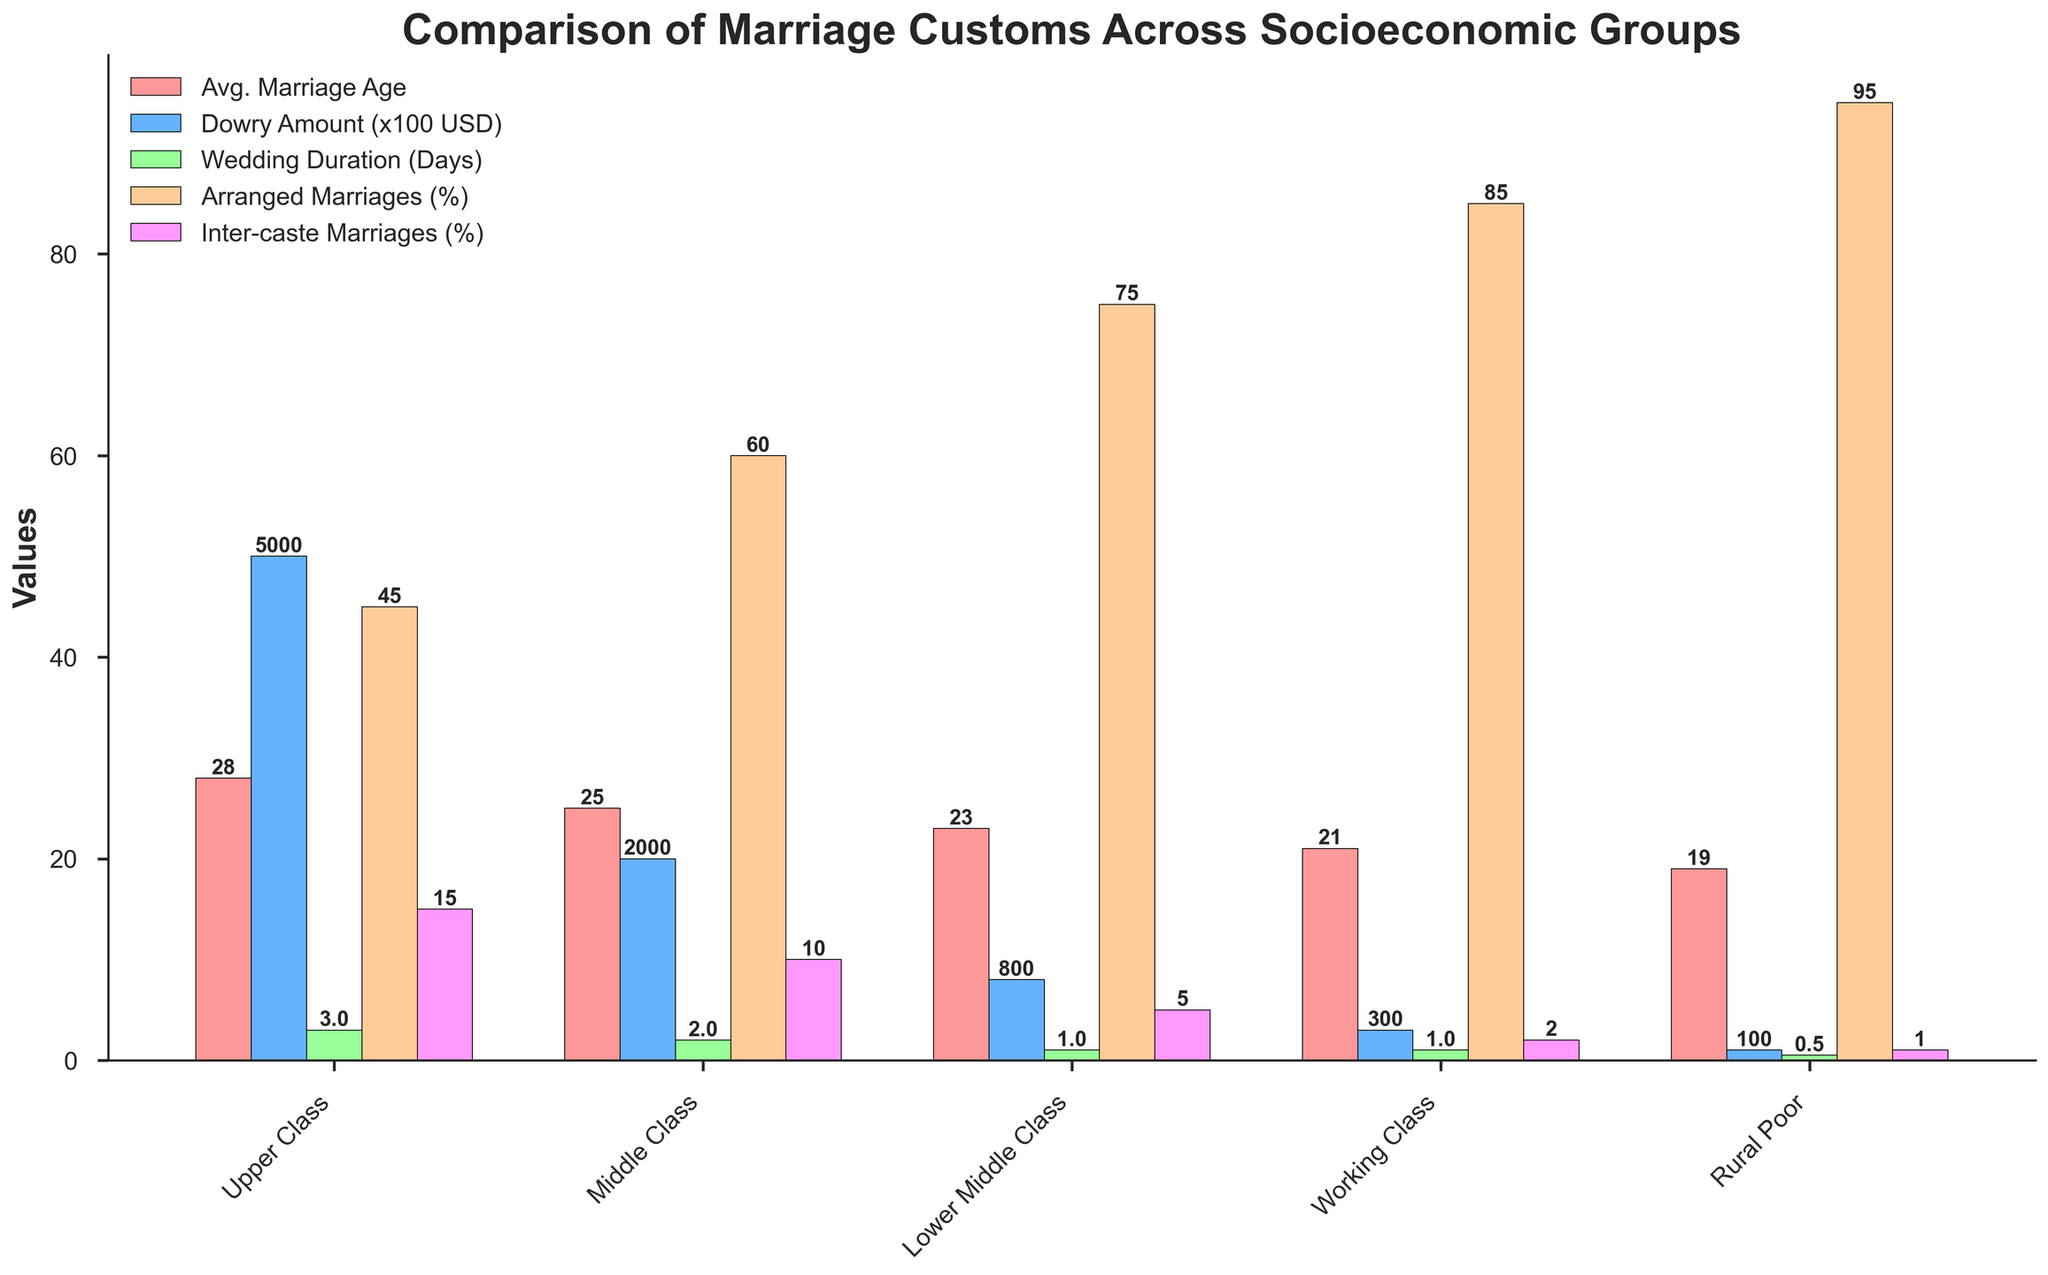What is the average marriage age for the middle-class group? The average marriage age for each socioeconomic group is shown as the first (leftmost) set of bars. For the middle-class group, which is the second category from the left, the height of the red bar represents the average marriage age.
Answer: 25 Which group has the highest arranged marriage percentage? The arranged marriages percentage for each group is displayed as the fourth set of bars. By comparing the height of the bars, the tallest one indicates the highest percentage. The tallest bar for arranged marriages is in the last group (Rural Poor).
Answer: Rural Poor How much more is the dowry amount in the upper class than in the working class? The dowry amount for each socioeconomic group is the second set of bars from the left. Compare the height of the bars for the upper class and working class to find the difference. The upper class is 5000 USD and the working class is 300 USD. The difference is 5000 - 300.
Answer: 4700 USD What is the total wedding duration for lower middle class and working class combined? The wedding duration is the third set of bars, displaying the height proportional to the number of days. For the lower middle class (third group) and the working class (fourth group), the values are 1 day each. Add the values: 1 day + 1 day = 2 days.
Answer: 2 days How many more percentage points of inter-caste marriages are there in the upper class than in the middle class? Inter-caste marriage percentage is the last set of bars, where the upper-class value is 15% and the middle-class value is 10%. Subtract the middle-class percentage from the upper-class percentage to get the difference: 15% - 10%.
Answer: 5 percentage points Which group has the shortest average wedding duration, and what is its value? The wedding duration is represented by the third set of bars. The shortest bar indicates the shortest duration. The bar for the Rural Poor group (last category) is the shortest, and it represents 0.5 days.
Answer: Rural Poor, 0.5 days Which groups have an average marriage age less than 25 years? The first set of bars denotes the average marriage age. Identify the bars that are shorter than the 25 marker. The groups are the Lower Middle Class, Working Class, and Rural Poor.
Answer: Lower Middle Class, Working Class, Rural Poor How much is the dowry amount in the middle class group when converted to USD? The second set of bars from the left shows the dowry amount. For the middle class, the bar represents 2000 USD.
Answer: 2000 USD What is the sum of arranged marriages percentages for the lower middle class and rural poor? The arranged marriages percentages are shown in the fourth set of bars. For the lower middle class, the percentage is 75%, and for the rural poor, it is 95%. The sum is 75% + 95%.
Answer: 170% Which socioeconomic group has the fewest inter-caste marriages percentage, and what is the value? The last set of bars represents the inter-caste marriage percentages. The shortest bar for this metric belongs to the Rural Poor group, which is 1%.
Answer: Rural Poor, 1% 